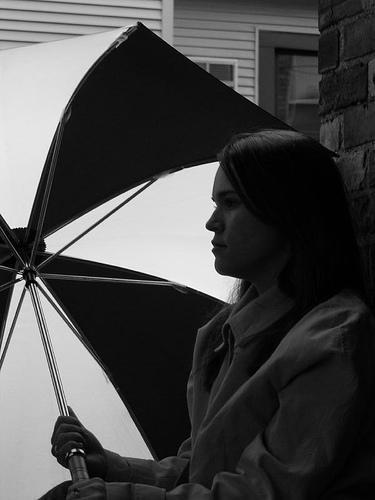How many people are pictured here?
Give a very brief answer. 1. How many windows can be seen on the building in the background?
Give a very brief answer. 2. How many people are shown?
Give a very brief answer. 1. How many hands are on the umbrella?
Give a very brief answer. 2. How many different colors are on the umbrella?
Give a very brief answer. 2. How many brown cats are there?
Give a very brief answer. 0. 